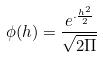<formula> <loc_0><loc_0><loc_500><loc_500>\phi ( h ) = \frac { e ^ { \cdot \frac { h ^ { 2 } } { 2 } } } { \sqrt { 2 \Pi } }</formula> 